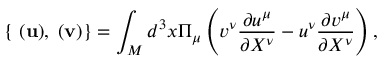Convert formula to latex. <formula><loc_0><loc_0><loc_500><loc_500>{ } \{ { \Pi } ( { u } ) , { \Pi } ( { v } ) \} = \int _ { M } d ^ { 3 } x \Pi _ { \mu } \left ( v ^ { \nu } \frac { \partial u ^ { \mu } } { \partial X ^ { \nu } } - u ^ { \nu } \frac { \partial v ^ { \mu } } { \partial X ^ { \nu } } \right ) ,</formula> 